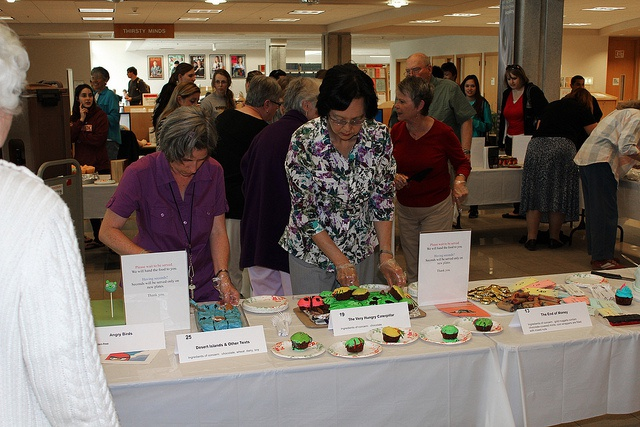Describe the objects in this image and their specific colors. I can see dining table in brown, darkgray, lightgray, and tan tones, people in brown, lightgray, black, maroon, and darkgray tones, people in brown, black, gray, darkgray, and maroon tones, people in brown, black, and maroon tones, and people in brown, black, and maroon tones in this image. 